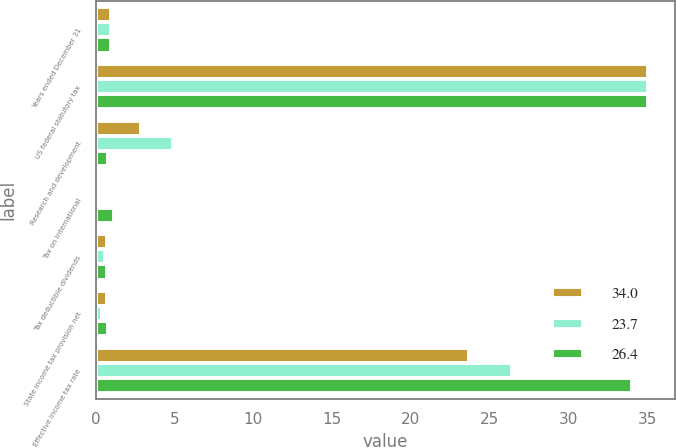<chart> <loc_0><loc_0><loc_500><loc_500><stacked_bar_chart><ecel><fcel>Years ended December 31<fcel>US federal statutory tax<fcel>Research and development<fcel>Tax on international<fcel>Tax deductible dividends<fcel>State income tax provision net<fcel>Effective income tax rate<nl><fcel>34<fcel>1<fcel>35<fcel>2.9<fcel>0.2<fcel>0.7<fcel>0.7<fcel>23.7<nl><fcel>23.7<fcel>1<fcel>35<fcel>4.9<fcel>0.1<fcel>0.6<fcel>0.4<fcel>26.4<nl><fcel>26.4<fcel>1<fcel>35<fcel>0.8<fcel>1.2<fcel>0.7<fcel>0.8<fcel>34<nl></chart> 